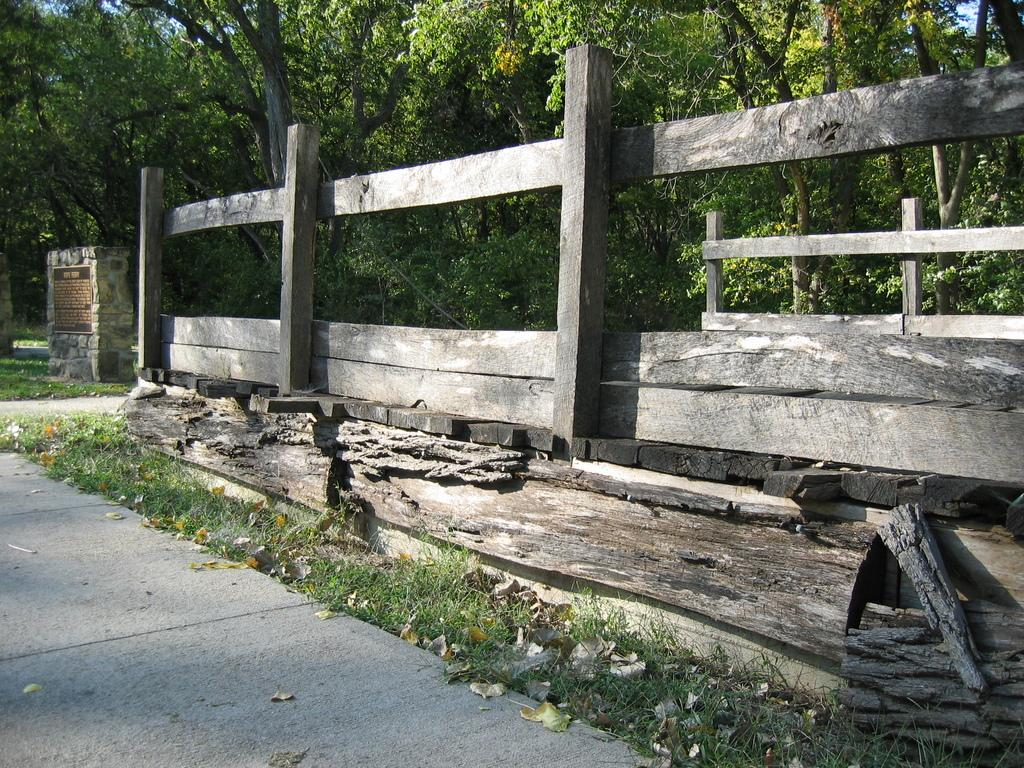What type of vegetation is in the foreground of the image? There is grass in the foreground of the image. What type of barrier is present in the foreground of the image? There is a wooden fence in the foreground of the image. What can be seen in the background of the image? There are trees and the sky visible in the background of the image. What time of day is the image likely taken? The image is likely taken during the day, as the sky is visible and not dark. What type of meat is the crook holding in the image? There is no crook or meat present in the image. What advice does the mother give to the child in the image? There is no mother or child present in the image. 